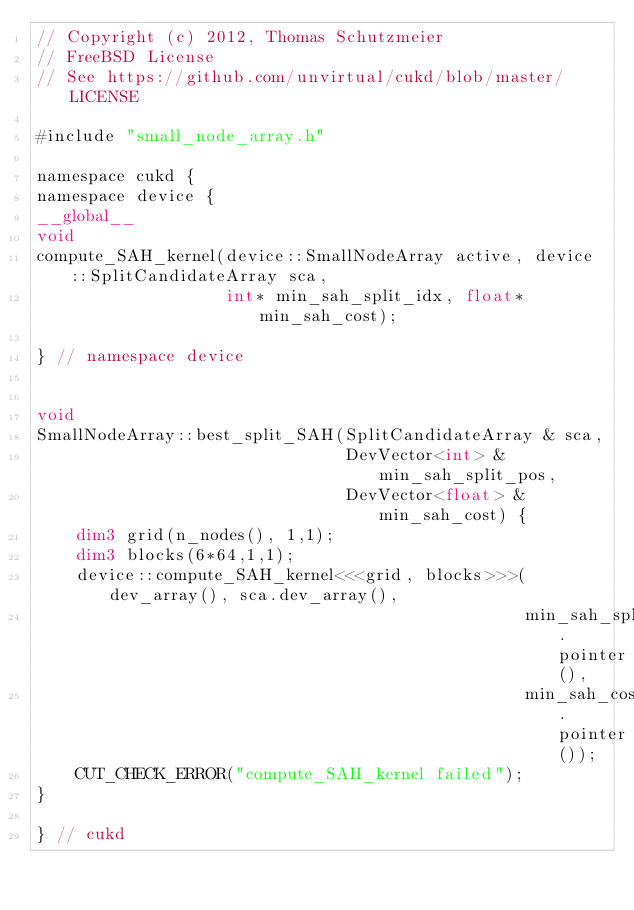Convert code to text. <code><loc_0><loc_0><loc_500><loc_500><_Cuda_>// Copyright (c) 2012, Thomas Schutzmeier
// FreeBSD License
// See https://github.com/unvirtual/cukd/blob/master/LICENSE

#include "small_node_array.h"

namespace cukd {
namespace device {
__global__
void
compute_SAH_kernel(device::SmallNodeArray active, device::SplitCandidateArray sca,
                   int* min_sah_split_idx, float* min_sah_cost);

} // namespace device


void
SmallNodeArray::best_split_SAH(SplitCandidateArray & sca,
                               DevVector<int> & min_sah_split_pos,
                               DevVector<float> & min_sah_cost) {
    dim3 grid(n_nodes(), 1,1);
    dim3 blocks(6*64,1,1);
    device::compute_SAH_kernel<<<grid, blocks>>>(dev_array(), sca.dev_array(),
                                                 min_sah_split_pos.pointer(),
                                                 min_sah_cost.pointer());
    CUT_CHECK_ERROR("compute_SAH_kernel failed");
}

} // cukd
</code> 